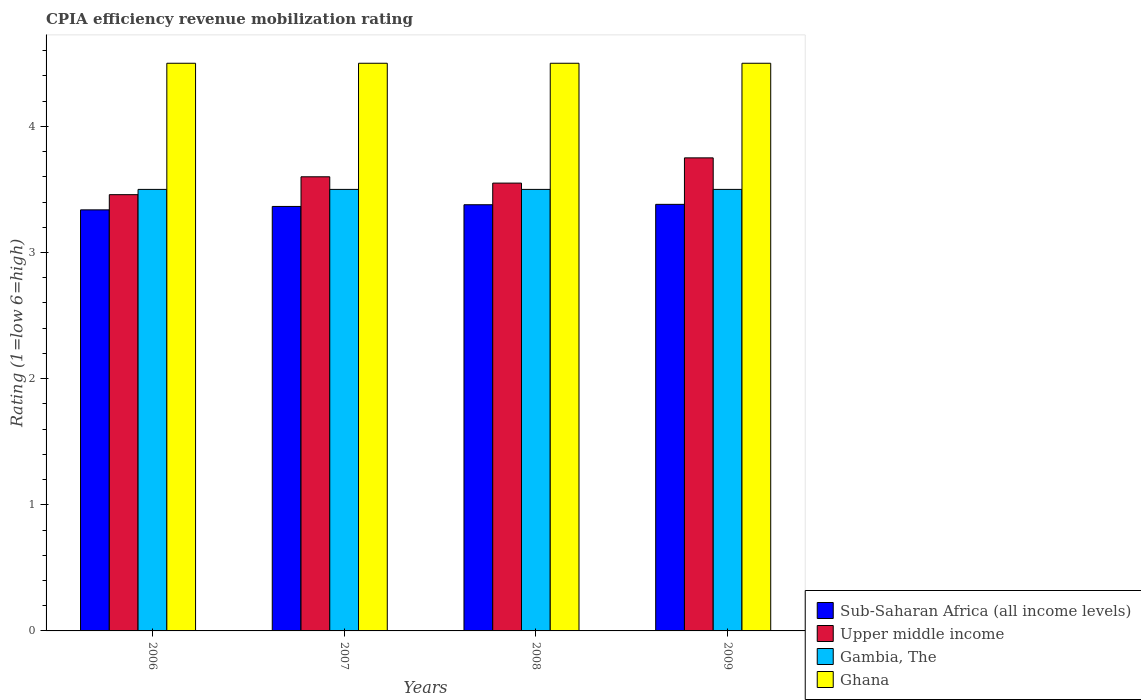How many different coloured bars are there?
Give a very brief answer. 4. Are the number of bars on each tick of the X-axis equal?
Provide a short and direct response. Yes. How many bars are there on the 2nd tick from the left?
Your answer should be very brief. 4. What is the label of the 2nd group of bars from the left?
Your answer should be compact. 2007. Across all years, what is the maximum CPIA rating in Sub-Saharan Africa (all income levels)?
Provide a short and direct response. 3.38. Across all years, what is the minimum CPIA rating in Gambia, The?
Your answer should be very brief. 3.5. In which year was the CPIA rating in Sub-Saharan Africa (all income levels) maximum?
Offer a very short reply. 2009. What is the total CPIA rating in Ghana in the graph?
Make the answer very short. 18. What is the difference between the CPIA rating in Upper middle income in 2006 and that in 2009?
Your response must be concise. -0.29. What is the difference between the CPIA rating in Upper middle income in 2007 and the CPIA rating in Gambia, The in 2006?
Your answer should be very brief. 0.1. What is the average CPIA rating in Upper middle income per year?
Provide a short and direct response. 3.59. In the year 2009, what is the difference between the CPIA rating in Gambia, The and CPIA rating in Sub-Saharan Africa (all income levels)?
Make the answer very short. 0.12. What is the ratio of the CPIA rating in Sub-Saharan Africa (all income levels) in 2008 to that in 2009?
Your response must be concise. 1. What is the difference between the highest and the second highest CPIA rating in Ghana?
Keep it short and to the point. 0. What is the difference between the highest and the lowest CPIA rating in Gambia, The?
Offer a very short reply. 0. In how many years, is the CPIA rating in Sub-Saharan Africa (all income levels) greater than the average CPIA rating in Sub-Saharan Africa (all income levels) taken over all years?
Give a very brief answer. 2. What does the 3rd bar from the left in 2007 represents?
Give a very brief answer. Gambia, The. Is it the case that in every year, the sum of the CPIA rating in Ghana and CPIA rating in Sub-Saharan Africa (all income levels) is greater than the CPIA rating in Gambia, The?
Provide a short and direct response. Yes. How many bars are there?
Give a very brief answer. 16. Are all the bars in the graph horizontal?
Provide a short and direct response. No. How many years are there in the graph?
Offer a terse response. 4. Are the values on the major ticks of Y-axis written in scientific E-notation?
Provide a succinct answer. No. What is the title of the graph?
Keep it short and to the point. CPIA efficiency revenue mobilization rating. Does "Slovenia" appear as one of the legend labels in the graph?
Ensure brevity in your answer.  No. What is the Rating (1=low 6=high) of Sub-Saharan Africa (all income levels) in 2006?
Make the answer very short. 3.34. What is the Rating (1=low 6=high) of Upper middle income in 2006?
Make the answer very short. 3.46. What is the Rating (1=low 6=high) in Ghana in 2006?
Give a very brief answer. 4.5. What is the Rating (1=low 6=high) of Sub-Saharan Africa (all income levels) in 2007?
Keep it short and to the point. 3.36. What is the Rating (1=low 6=high) in Gambia, The in 2007?
Your answer should be compact. 3.5. What is the Rating (1=low 6=high) of Ghana in 2007?
Make the answer very short. 4.5. What is the Rating (1=low 6=high) in Sub-Saharan Africa (all income levels) in 2008?
Offer a terse response. 3.38. What is the Rating (1=low 6=high) of Upper middle income in 2008?
Keep it short and to the point. 3.55. What is the Rating (1=low 6=high) in Gambia, The in 2008?
Give a very brief answer. 3.5. What is the Rating (1=low 6=high) of Sub-Saharan Africa (all income levels) in 2009?
Your answer should be compact. 3.38. What is the Rating (1=low 6=high) of Upper middle income in 2009?
Provide a succinct answer. 3.75. Across all years, what is the maximum Rating (1=low 6=high) in Sub-Saharan Africa (all income levels)?
Ensure brevity in your answer.  3.38. Across all years, what is the maximum Rating (1=low 6=high) of Upper middle income?
Your response must be concise. 3.75. Across all years, what is the maximum Rating (1=low 6=high) in Ghana?
Your response must be concise. 4.5. Across all years, what is the minimum Rating (1=low 6=high) in Sub-Saharan Africa (all income levels)?
Your answer should be very brief. 3.34. Across all years, what is the minimum Rating (1=low 6=high) of Upper middle income?
Give a very brief answer. 3.46. What is the total Rating (1=low 6=high) of Sub-Saharan Africa (all income levels) in the graph?
Make the answer very short. 13.46. What is the total Rating (1=low 6=high) in Upper middle income in the graph?
Ensure brevity in your answer.  14.36. What is the total Rating (1=low 6=high) of Gambia, The in the graph?
Make the answer very short. 14. What is the difference between the Rating (1=low 6=high) in Sub-Saharan Africa (all income levels) in 2006 and that in 2007?
Provide a succinct answer. -0.03. What is the difference between the Rating (1=low 6=high) of Upper middle income in 2006 and that in 2007?
Keep it short and to the point. -0.14. What is the difference between the Rating (1=low 6=high) in Gambia, The in 2006 and that in 2007?
Make the answer very short. 0. What is the difference between the Rating (1=low 6=high) of Ghana in 2006 and that in 2007?
Provide a succinct answer. 0. What is the difference between the Rating (1=low 6=high) in Sub-Saharan Africa (all income levels) in 2006 and that in 2008?
Offer a very short reply. -0.04. What is the difference between the Rating (1=low 6=high) of Upper middle income in 2006 and that in 2008?
Give a very brief answer. -0.09. What is the difference between the Rating (1=low 6=high) of Gambia, The in 2006 and that in 2008?
Your response must be concise. 0. What is the difference between the Rating (1=low 6=high) of Ghana in 2006 and that in 2008?
Offer a very short reply. 0. What is the difference between the Rating (1=low 6=high) in Sub-Saharan Africa (all income levels) in 2006 and that in 2009?
Keep it short and to the point. -0.04. What is the difference between the Rating (1=low 6=high) of Upper middle income in 2006 and that in 2009?
Provide a succinct answer. -0.29. What is the difference between the Rating (1=low 6=high) in Gambia, The in 2006 and that in 2009?
Your response must be concise. 0. What is the difference between the Rating (1=low 6=high) of Ghana in 2006 and that in 2009?
Ensure brevity in your answer.  0. What is the difference between the Rating (1=low 6=high) in Sub-Saharan Africa (all income levels) in 2007 and that in 2008?
Your answer should be compact. -0.01. What is the difference between the Rating (1=low 6=high) in Upper middle income in 2007 and that in 2008?
Provide a succinct answer. 0.05. What is the difference between the Rating (1=low 6=high) in Sub-Saharan Africa (all income levels) in 2007 and that in 2009?
Your answer should be very brief. -0.02. What is the difference between the Rating (1=low 6=high) in Upper middle income in 2007 and that in 2009?
Ensure brevity in your answer.  -0.15. What is the difference between the Rating (1=low 6=high) in Ghana in 2007 and that in 2009?
Provide a short and direct response. 0. What is the difference between the Rating (1=low 6=high) of Sub-Saharan Africa (all income levels) in 2008 and that in 2009?
Your answer should be very brief. -0. What is the difference between the Rating (1=low 6=high) in Upper middle income in 2008 and that in 2009?
Your response must be concise. -0.2. What is the difference between the Rating (1=low 6=high) in Sub-Saharan Africa (all income levels) in 2006 and the Rating (1=low 6=high) in Upper middle income in 2007?
Offer a terse response. -0.26. What is the difference between the Rating (1=low 6=high) in Sub-Saharan Africa (all income levels) in 2006 and the Rating (1=low 6=high) in Gambia, The in 2007?
Your answer should be very brief. -0.16. What is the difference between the Rating (1=low 6=high) of Sub-Saharan Africa (all income levels) in 2006 and the Rating (1=low 6=high) of Ghana in 2007?
Give a very brief answer. -1.16. What is the difference between the Rating (1=low 6=high) in Upper middle income in 2006 and the Rating (1=low 6=high) in Gambia, The in 2007?
Offer a very short reply. -0.04. What is the difference between the Rating (1=low 6=high) of Upper middle income in 2006 and the Rating (1=low 6=high) of Ghana in 2007?
Make the answer very short. -1.04. What is the difference between the Rating (1=low 6=high) in Sub-Saharan Africa (all income levels) in 2006 and the Rating (1=low 6=high) in Upper middle income in 2008?
Offer a very short reply. -0.21. What is the difference between the Rating (1=low 6=high) in Sub-Saharan Africa (all income levels) in 2006 and the Rating (1=low 6=high) in Gambia, The in 2008?
Offer a very short reply. -0.16. What is the difference between the Rating (1=low 6=high) in Sub-Saharan Africa (all income levels) in 2006 and the Rating (1=low 6=high) in Ghana in 2008?
Offer a terse response. -1.16. What is the difference between the Rating (1=low 6=high) in Upper middle income in 2006 and the Rating (1=low 6=high) in Gambia, The in 2008?
Keep it short and to the point. -0.04. What is the difference between the Rating (1=low 6=high) of Upper middle income in 2006 and the Rating (1=low 6=high) of Ghana in 2008?
Provide a short and direct response. -1.04. What is the difference between the Rating (1=low 6=high) in Sub-Saharan Africa (all income levels) in 2006 and the Rating (1=low 6=high) in Upper middle income in 2009?
Your answer should be compact. -0.41. What is the difference between the Rating (1=low 6=high) in Sub-Saharan Africa (all income levels) in 2006 and the Rating (1=low 6=high) in Gambia, The in 2009?
Your answer should be very brief. -0.16. What is the difference between the Rating (1=low 6=high) of Sub-Saharan Africa (all income levels) in 2006 and the Rating (1=low 6=high) of Ghana in 2009?
Provide a succinct answer. -1.16. What is the difference between the Rating (1=low 6=high) in Upper middle income in 2006 and the Rating (1=low 6=high) in Gambia, The in 2009?
Provide a succinct answer. -0.04. What is the difference between the Rating (1=low 6=high) in Upper middle income in 2006 and the Rating (1=low 6=high) in Ghana in 2009?
Your answer should be very brief. -1.04. What is the difference between the Rating (1=low 6=high) in Sub-Saharan Africa (all income levels) in 2007 and the Rating (1=low 6=high) in Upper middle income in 2008?
Offer a terse response. -0.19. What is the difference between the Rating (1=low 6=high) of Sub-Saharan Africa (all income levels) in 2007 and the Rating (1=low 6=high) of Gambia, The in 2008?
Provide a succinct answer. -0.14. What is the difference between the Rating (1=low 6=high) of Sub-Saharan Africa (all income levels) in 2007 and the Rating (1=low 6=high) of Ghana in 2008?
Give a very brief answer. -1.14. What is the difference between the Rating (1=low 6=high) of Upper middle income in 2007 and the Rating (1=low 6=high) of Gambia, The in 2008?
Provide a succinct answer. 0.1. What is the difference between the Rating (1=low 6=high) in Upper middle income in 2007 and the Rating (1=low 6=high) in Ghana in 2008?
Give a very brief answer. -0.9. What is the difference between the Rating (1=low 6=high) in Sub-Saharan Africa (all income levels) in 2007 and the Rating (1=low 6=high) in Upper middle income in 2009?
Offer a very short reply. -0.39. What is the difference between the Rating (1=low 6=high) of Sub-Saharan Africa (all income levels) in 2007 and the Rating (1=low 6=high) of Gambia, The in 2009?
Your answer should be very brief. -0.14. What is the difference between the Rating (1=low 6=high) of Sub-Saharan Africa (all income levels) in 2007 and the Rating (1=low 6=high) of Ghana in 2009?
Offer a terse response. -1.14. What is the difference between the Rating (1=low 6=high) in Upper middle income in 2007 and the Rating (1=low 6=high) in Gambia, The in 2009?
Ensure brevity in your answer.  0.1. What is the difference between the Rating (1=low 6=high) of Sub-Saharan Africa (all income levels) in 2008 and the Rating (1=low 6=high) of Upper middle income in 2009?
Your answer should be very brief. -0.37. What is the difference between the Rating (1=low 6=high) of Sub-Saharan Africa (all income levels) in 2008 and the Rating (1=low 6=high) of Gambia, The in 2009?
Offer a very short reply. -0.12. What is the difference between the Rating (1=low 6=high) of Sub-Saharan Africa (all income levels) in 2008 and the Rating (1=low 6=high) of Ghana in 2009?
Offer a terse response. -1.12. What is the difference between the Rating (1=low 6=high) of Upper middle income in 2008 and the Rating (1=low 6=high) of Gambia, The in 2009?
Provide a short and direct response. 0.05. What is the difference between the Rating (1=low 6=high) of Upper middle income in 2008 and the Rating (1=low 6=high) of Ghana in 2009?
Give a very brief answer. -0.95. What is the difference between the Rating (1=low 6=high) in Gambia, The in 2008 and the Rating (1=low 6=high) in Ghana in 2009?
Your answer should be compact. -1. What is the average Rating (1=low 6=high) in Sub-Saharan Africa (all income levels) per year?
Offer a terse response. 3.37. What is the average Rating (1=low 6=high) in Upper middle income per year?
Your answer should be compact. 3.59. In the year 2006, what is the difference between the Rating (1=low 6=high) of Sub-Saharan Africa (all income levels) and Rating (1=low 6=high) of Upper middle income?
Offer a very short reply. -0.12. In the year 2006, what is the difference between the Rating (1=low 6=high) in Sub-Saharan Africa (all income levels) and Rating (1=low 6=high) in Gambia, The?
Offer a very short reply. -0.16. In the year 2006, what is the difference between the Rating (1=low 6=high) of Sub-Saharan Africa (all income levels) and Rating (1=low 6=high) of Ghana?
Ensure brevity in your answer.  -1.16. In the year 2006, what is the difference between the Rating (1=low 6=high) in Upper middle income and Rating (1=low 6=high) in Gambia, The?
Your answer should be very brief. -0.04. In the year 2006, what is the difference between the Rating (1=low 6=high) in Upper middle income and Rating (1=low 6=high) in Ghana?
Your answer should be compact. -1.04. In the year 2007, what is the difference between the Rating (1=low 6=high) in Sub-Saharan Africa (all income levels) and Rating (1=low 6=high) in Upper middle income?
Provide a succinct answer. -0.24. In the year 2007, what is the difference between the Rating (1=low 6=high) in Sub-Saharan Africa (all income levels) and Rating (1=low 6=high) in Gambia, The?
Your answer should be compact. -0.14. In the year 2007, what is the difference between the Rating (1=low 6=high) in Sub-Saharan Africa (all income levels) and Rating (1=low 6=high) in Ghana?
Offer a very short reply. -1.14. In the year 2007, what is the difference between the Rating (1=low 6=high) of Upper middle income and Rating (1=low 6=high) of Gambia, The?
Keep it short and to the point. 0.1. In the year 2007, what is the difference between the Rating (1=low 6=high) of Upper middle income and Rating (1=low 6=high) of Ghana?
Your answer should be compact. -0.9. In the year 2008, what is the difference between the Rating (1=low 6=high) in Sub-Saharan Africa (all income levels) and Rating (1=low 6=high) in Upper middle income?
Offer a terse response. -0.17. In the year 2008, what is the difference between the Rating (1=low 6=high) in Sub-Saharan Africa (all income levels) and Rating (1=low 6=high) in Gambia, The?
Keep it short and to the point. -0.12. In the year 2008, what is the difference between the Rating (1=low 6=high) of Sub-Saharan Africa (all income levels) and Rating (1=low 6=high) of Ghana?
Make the answer very short. -1.12. In the year 2008, what is the difference between the Rating (1=low 6=high) of Upper middle income and Rating (1=low 6=high) of Gambia, The?
Your answer should be very brief. 0.05. In the year 2008, what is the difference between the Rating (1=low 6=high) in Upper middle income and Rating (1=low 6=high) in Ghana?
Offer a terse response. -0.95. In the year 2009, what is the difference between the Rating (1=low 6=high) in Sub-Saharan Africa (all income levels) and Rating (1=low 6=high) in Upper middle income?
Offer a very short reply. -0.37. In the year 2009, what is the difference between the Rating (1=low 6=high) in Sub-Saharan Africa (all income levels) and Rating (1=low 6=high) in Gambia, The?
Offer a very short reply. -0.12. In the year 2009, what is the difference between the Rating (1=low 6=high) in Sub-Saharan Africa (all income levels) and Rating (1=low 6=high) in Ghana?
Make the answer very short. -1.12. In the year 2009, what is the difference between the Rating (1=low 6=high) in Upper middle income and Rating (1=low 6=high) in Ghana?
Your answer should be compact. -0.75. In the year 2009, what is the difference between the Rating (1=low 6=high) of Gambia, The and Rating (1=low 6=high) of Ghana?
Your response must be concise. -1. What is the ratio of the Rating (1=low 6=high) in Sub-Saharan Africa (all income levels) in 2006 to that in 2007?
Provide a succinct answer. 0.99. What is the ratio of the Rating (1=low 6=high) of Upper middle income in 2006 to that in 2007?
Provide a short and direct response. 0.96. What is the ratio of the Rating (1=low 6=high) of Gambia, The in 2006 to that in 2007?
Keep it short and to the point. 1. What is the ratio of the Rating (1=low 6=high) of Sub-Saharan Africa (all income levels) in 2006 to that in 2008?
Provide a succinct answer. 0.99. What is the ratio of the Rating (1=low 6=high) of Upper middle income in 2006 to that in 2008?
Ensure brevity in your answer.  0.97. What is the ratio of the Rating (1=low 6=high) of Gambia, The in 2006 to that in 2008?
Keep it short and to the point. 1. What is the ratio of the Rating (1=low 6=high) of Sub-Saharan Africa (all income levels) in 2006 to that in 2009?
Your response must be concise. 0.99. What is the ratio of the Rating (1=low 6=high) of Upper middle income in 2006 to that in 2009?
Give a very brief answer. 0.92. What is the ratio of the Rating (1=low 6=high) in Gambia, The in 2006 to that in 2009?
Make the answer very short. 1. What is the ratio of the Rating (1=low 6=high) of Upper middle income in 2007 to that in 2008?
Give a very brief answer. 1.01. What is the ratio of the Rating (1=low 6=high) in Gambia, The in 2007 to that in 2008?
Provide a short and direct response. 1. What is the ratio of the Rating (1=low 6=high) of Ghana in 2007 to that in 2008?
Your response must be concise. 1. What is the ratio of the Rating (1=low 6=high) of Upper middle income in 2007 to that in 2009?
Keep it short and to the point. 0.96. What is the ratio of the Rating (1=low 6=high) in Gambia, The in 2007 to that in 2009?
Your response must be concise. 1. What is the ratio of the Rating (1=low 6=high) of Ghana in 2007 to that in 2009?
Ensure brevity in your answer.  1. What is the ratio of the Rating (1=low 6=high) of Upper middle income in 2008 to that in 2009?
Your answer should be very brief. 0.95. What is the ratio of the Rating (1=low 6=high) in Gambia, The in 2008 to that in 2009?
Provide a short and direct response. 1. What is the ratio of the Rating (1=low 6=high) in Ghana in 2008 to that in 2009?
Provide a succinct answer. 1. What is the difference between the highest and the second highest Rating (1=low 6=high) in Sub-Saharan Africa (all income levels)?
Give a very brief answer. 0. What is the difference between the highest and the second highest Rating (1=low 6=high) in Gambia, The?
Provide a succinct answer. 0. What is the difference between the highest and the lowest Rating (1=low 6=high) in Sub-Saharan Africa (all income levels)?
Give a very brief answer. 0.04. What is the difference between the highest and the lowest Rating (1=low 6=high) in Upper middle income?
Offer a terse response. 0.29. What is the difference between the highest and the lowest Rating (1=low 6=high) of Gambia, The?
Your answer should be very brief. 0. What is the difference between the highest and the lowest Rating (1=low 6=high) of Ghana?
Ensure brevity in your answer.  0. 